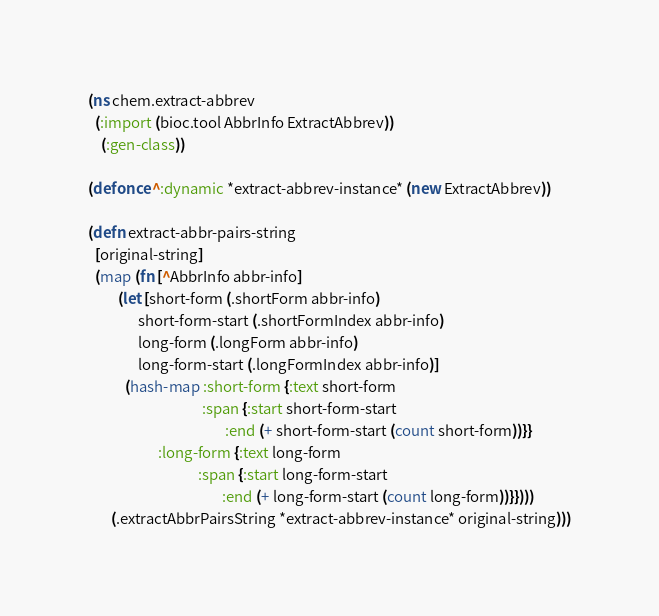Convert code to text. <code><loc_0><loc_0><loc_500><loc_500><_Clojure_>(ns chem.extract-abbrev
  (:import (bioc.tool AbbrInfo ExtractAbbrev))
    (:gen-class))

(defonce ^:dynamic *extract-abbrev-instance* (new ExtractAbbrev))

(defn extract-abbr-pairs-string 
  [original-string]
  (map (fn [^AbbrInfo abbr-info]
         (let [short-form (.shortForm abbr-info)
               short-form-start (.shortFormIndex abbr-info)
               long-form (.longForm abbr-info)
               long-form-start (.longFormIndex abbr-info)]
           (hash-map :short-form {:text short-form
                                  :span {:start short-form-start
                                         :end (+ short-form-start (count short-form))}}
                     :long-form {:text long-form
                                 :span {:start long-form-start
                                        :end (+ long-form-start (count long-form))}})))
       (.extractAbbrPairsString *extract-abbrev-instance* original-string)))
</code> 